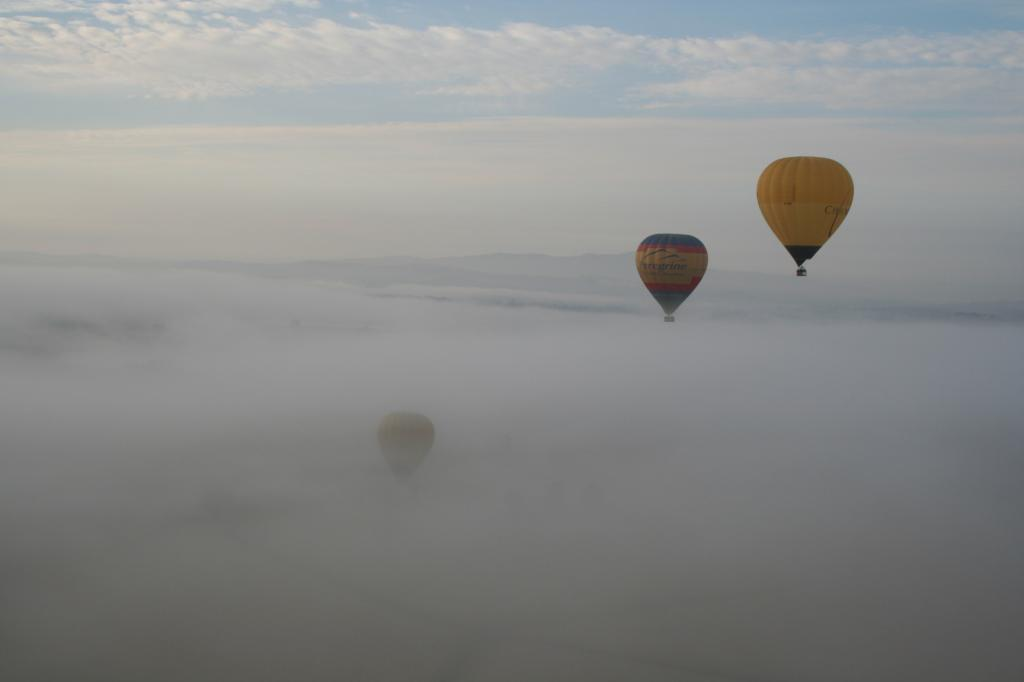What is the main subject of the image? The main subject of the image is a hot air balloon. What is the condition of the hot air balloon in the image? The hot air balloon is in the fog. What type of landscape can be seen in the image? Hills are visible in the image. What part of the natural environment is visible in the image? The sky is visible in the image, and clouds are present in the sky. What type of feather can be seen in the hot air balloon's basket in the image? There is no feather present in the hot air balloon's basket in the image. What type of competition is taking place between the hot air balloons in the image? There is only one hot air balloon visible in the image, and no competition is taking place. 